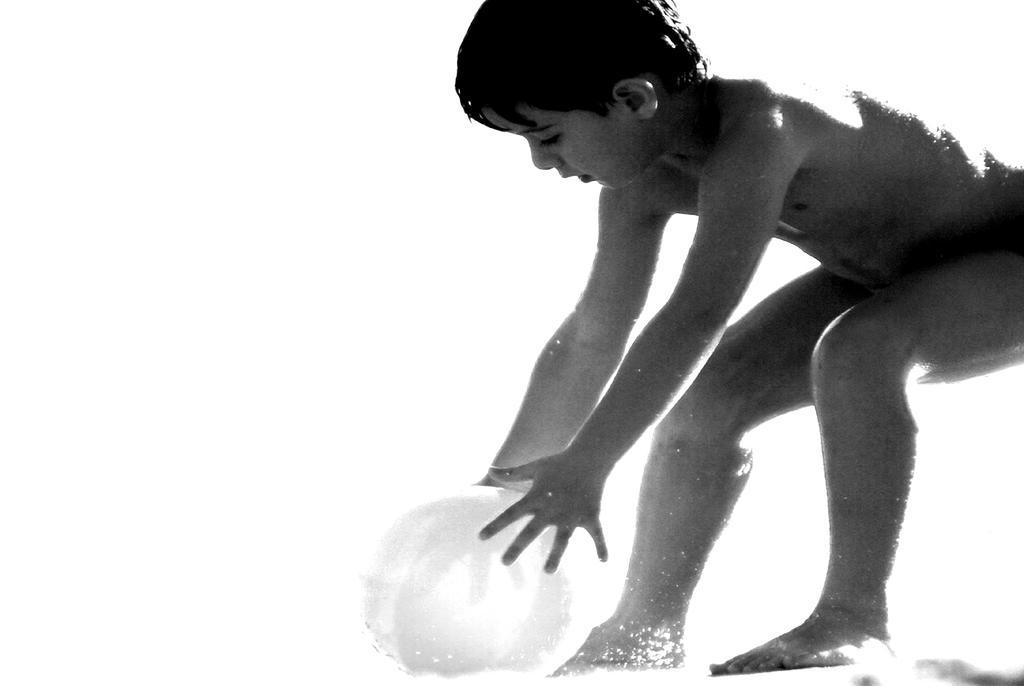Describe this image in one or two sentences. In this picture we can see a kid holding a ball. 